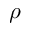<formula> <loc_0><loc_0><loc_500><loc_500>\rho</formula> 